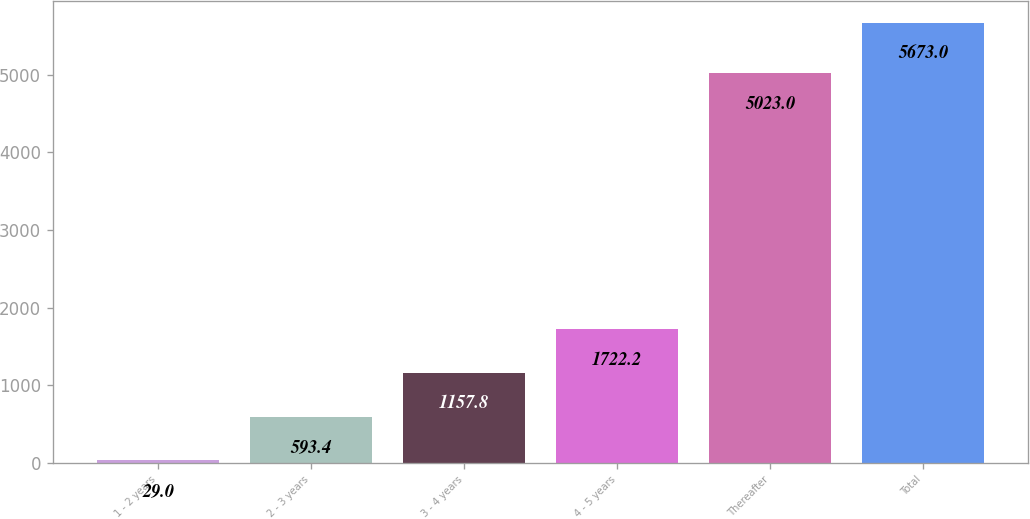<chart> <loc_0><loc_0><loc_500><loc_500><bar_chart><fcel>1 - 2 years<fcel>2 - 3 years<fcel>3 - 4 years<fcel>4 - 5 years<fcel>Thereafter<fcel>Total<nl><fcel>29<fcel>593.4<fcel>1157.8<fcel>1722.2<fcel>5023<fcel>5673<nl></chart> 